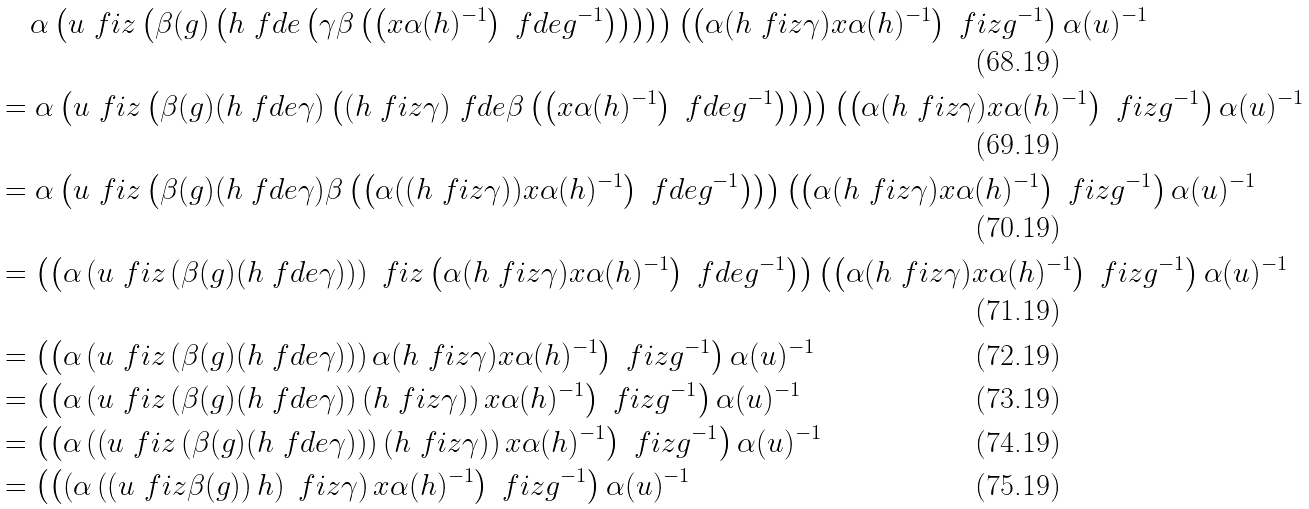<formula> <loc_0><loc_0><loc_500><loc_500>& \quad \, \alpha \left ( u \ f i z \left ( \beta ( g ) \left ( h \ f d e \left ( \gamma \beta \left ( \left ( x \alpha ( h ) ^ { - 1 } \right ) \ f d e g ^ { - 1 } \right ) \right ) \right ) \right ) \right ) \left ( \left ( \alpha ( h \ f i z \gamma ) x \alpha ( h ) ^ { - 1 } \right ) \ f i z g ^ { - 1 } \right ) \alpha ( u ) ^ { - 1 } \\ & = \alpha \left ( u \ f i z \left ( \beta ( g ) ( h \ f d e \gamma ) \left ( ( h \ f i z \gamma ) \ f d e \beta \left ( \left ( x \alpha ( h ) ^ { - 1 } \right ) \ f d e g ^ { - 1 } \right ) \right ) \right ) \right ) \left ( \left ( \alpha ( h \ f i z \gamma ) x \alpha ( h ) ^ { - 1 } \right ) \ f i z g ^ { - 1 } \right ) \alpha ( u ) ^ { - 1 } \\ & = \alpha \left ( u \ f i z \left ( \beta ( g ) ( h \ f d e \gamma ) \beta \left ( \left ( \alpha ( ( h \ f i z \gamma ) ) x \alpha ( h ) ^ { - 1 } \right ) \ f d e g ^ { - 1 } \right ) \right ) \right ) \left ( \left ( \alpha ( h \ f i z \gamma ) x \alpha ( h ) ^ { - 1 } \right ) \ f i z g ^ { - 1 } \right ) \alpha ( u ) ^ { - 1 } \\ & = \left ( \left ( \alpha \left ( u \ f i z \left ( \beta ( g ) ( h \ f d e \gamma ) \right ) \right ) \ f i z \left ( \alpha ( h \ f i z \gamma ) x \alpha ( h ) ^ { - 1 } \right ) \ f d e g ^ { - 1 } \right ) \right ) \left ( \left ( \alpha ( h \ f i z \gamma ) x \alpha ( h ) ^ { - 1 } \right ) \ f i z g ^ { - 1 } \right ) \alpha ( u ) ^ { - 1 } \\ & = \left ( \left ( \alpha \left ( u \ f i z \left ( \beta ( g ) ( h \ f d e \gamma ) \right ) \right ) \alpha ( h \ f i z \gamma ) x \alpha ( h ) ^ { - 1 } \right ) \ f i z g ^ { - 1 } \right ) \alpha ( u ) ^ { - 1 } \\ & = \left ( \left ( \alpha \left ( u \ f i z \left ( \beta ( g ) ( h \ f d e \gamma ) \right ) ( h \ f i z \gamma ) \right ) x \alpha ( h ) ^ { - 1 } \right ) \ f i z g ^ { - 1 } \right ) \alpha ( u ) ^ { - 1 } \\ & = \left ( \left ( \alpha \left ( \left ( u \ f i z \left ( \beta ( g ) ( h \ f d e \gamma ) \right ) \right ) ( h \ f i z \gamma ) \right ) x \alpha ( h ) ^ { - 1 } \right ) \ f i z g ^ { - 1 } \right ) \alpha ( u ) ^ { - 1 } \\ & = \left ( \left ( \left ( \alpha \left ( \left ( u \ f i z \beta ( g ) \right ) h \right ) \ f i z \gamma \right ) x \alpha ( h ) ^ { - 1 } \right ) \ f i z g ^ { - 1 } \right ) \alpha ( u ) ^ { - 1 }</formula> 